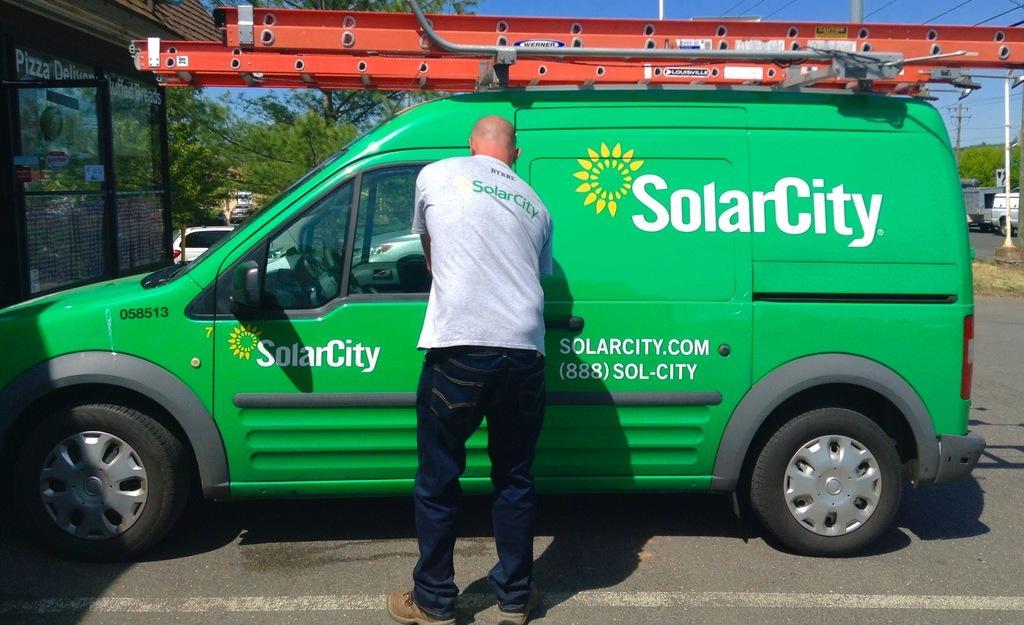Describe this image in one or two sentences. In this image there is a person locking the door of a car, in front of the car there is a glass window under a hut, on the other side of the car there are trees, cars and electric poles with cables on top of it. 